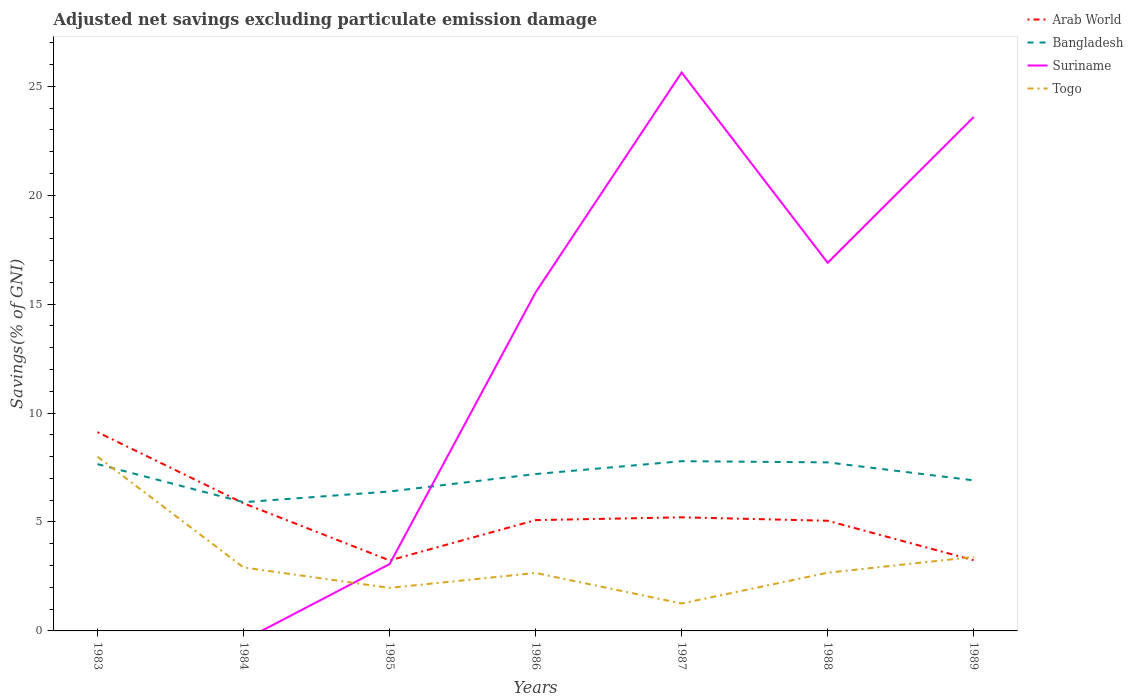Does the line corresponding to Togo intersect with the line corresponding to Arab World?
Offer a very short reply. Yes. Across all years, what is the maximum adjusted net savings in Togo?
Your answer should be compact. 1.26. What is the total adjusted net savings in Togo in the graph?
Keep it short and to the point. 0.24. What is the difference between the highest and the second highest adjusted net savings in Arab World?
Give a very brief answer. 5.89. What is the difference between the highest and the lowest adjusted net savings in Bangladesh?
Your answer should be compact. 4. Is the adjusted net savings in Suriname strictly greater than the adjusted net savings in Bangladesh over the years?
Offer a very short reply. No. How many lines are there?
Your response must be concise. 4. Are the values on the major ticks of Y-axis written in scientific E-notation?
Offer a terse response. No. Does the graph contain grids?
Provide a succinct answer. No. Where does the legend appear in the graph?
Offer a terse response. Top right. What is the title of the graph?
Your response must be concise. Adjusted net savings excluding particulate emission damage. Does "Syrian Arab Republic" appear as one of the legend labels in the graph?
Provide a succinct answer. No. What is the label or title of the Y-axis?
Your answer should be very brief. Savings(% of GNI). What is the Savings(% of GNI) in Arab World in 1983?
Make the answer very short. 9.12. What is the Savings(% of GNI) of Bangladesh in 1983?
Your response must be concise. 7.66. What is the Savings(% of GNI) in Togo in 1983?
Provide a succinct answer. 8. What is the Savings(% of GNI) in Arab World in 1984?
Keep it short and to the point. 5.86. What is the Savings(% of GNI) of Bangladesh in 1984?
Provide a short and direct response. 5.91. What is the Savings(% of GNI) in Togo in 1984?
Offer a very short reply. 2.91. What is the Savings(% of GNI) of Arab World in 1985?
Offer a very short reply. 3.24. What is the Savings(% of GNI) in Bangladesh in 1985?
Provide a succinct answer. 6.4. What is the Savings(% of GNI) of Suriname in 1985?
Offer a terse response. 3.07. What is the Savings(% of GNI) of Togo in 1985?
Offer a very short reply. 1.98. What is the Savings(% of GNI) in Arab World in 1986?
Your response must be concise. 5.09. What is the Savings(% of GNI) of Bangladesh in 1986?
Provide a succinct answer. 7.2. What is the Savings(% of GNI) of Suriname in 1986?
Your answer should be compact. 15.54. What is the Savings(% of GNI) of Togo in 1986?
Ensure brevity in your answer.  2.66. What is the Savings(% of GNI) of Arab World in 1987?
Provide a succinct answer. 5.22. What is the Savings(% of GNI) in Bangladesh in 1987?
Ensure brevity in your answer.  7.79. What is the Savings(% of GNI) in Suriname in 1987?
Offer a very short reply. 25.63. What is the Savings(% of GNI) in Togo in 1987?
Offer a terse response. 1.26. What is the Savings(% of GNI) in Arab World in 1988?
Ensure brevity in your answer.  5.06. What is the Savings(% of GNI) of Bangladesh in 1988?
Provide a succinct answer. 7.74. What is the Savings(% of GNI) in Suriname in 1988?
Offer a terse response. 16.9. What is the Savings(% of GNI) of Togo in 1988?
Make the answer very short. 2.67. What is the Savings(% of GNI) in Arab World in 1989?
Give a very brief answer. 3.24. What is the Savings(% of GNI) of Bangladesh in 1989?
Provide a short and direct response. 6.91. What is the Savings(% of GNI) in Suriname in 1989?
Keep it short and to the point. 23.59. What is the Savings(% of GNI) of Togo in 1989?
Provide a succinct answer. 3.4. Across all years, what is the maximum Savings(% of GNI) in Arab World?
Provide a succinct answer. 9.12. Across all years, what is the maximum Savings(% of GNI) of Bangladesh?
Your answer should be very brief. 7.79. Across all years, what is the maximum Savings(% of GNI) of Suriname?
Give a very brief answer. 25.63. Across all years, what is the maximum Savings(% of GNI) in Togo?
Keep it short and to the point. 8. Across all years, what is the minimum Savings(% of GNI) of Arab World?
Ensure brevity in your answer.  3.24. Across all years, what is the minimum Savings(% of GNI) in Bangladesh?
Make the answer very short. 5.91. Across all years, what is the minimum Savings(% of GNI) in Suriname?
Your answer should be very brief. 0. Across all years, what is the minimum Savings(% of GNI) in Togo?
Offer a very short reply. 1.26. What is the total Savings(% of GNI) of Arab World in the graph?
Ensure brevity in your answer.  36.82. What is the total Savings(% of GNI) of Bangladesh in the graph?
Make the answer very short. 49.61. What is the total Savings(% of GNI) in Suriname in the graph?
Keep it short and to the point. 84.73. What is the total Savings(% of GNI) of Togo in the graph?
Ensure brevity in your answer.  22.87. What is the difference between the Savings(% of GNI) in Arab World in 1983 and that in 1984?
Keep it short and to the point. 3.26. What is the difference between the Savings(% of GNI) in Bangladesh in 1983 and that in 1984?
Offer a terse response. 1.75. What is the difference between the Savings(% of GNI) of Togo in 1983 and that in 1984?
Your answer should be very brief. 5.08. What is the difference between the Savings(% of GNI) of Arab World in 1983 and that in 1985?
Provide a succinct answer. 5.89. What is the difference between the Savings(% of GNI) of Bangladesh in 1983 and that in 1985?
Ensure brevity in your answer.  1.26. What is the difference between the Savings(% of GNI) in Togo in 1983 and that in 1985?
Your answer should be compact. 6.02. What is the difference between the Savings(% of GNI) in Arab World in 1983 and that in 1986?
Make the answer very short. 4.04. What is the difference between the Savings(% of GNI) of Bangladesh in 1983 and that in 1986?
Your answer should be very brief. 0.45. What is the difference between the Savings(% of GNI) of Togo in 1983 and that in 1986?
Provide a short and direct response. 5.34. What is the difference between the Savings(% of GNI) in Arab World in 1983 and that in 1987?
Offer a very short reply. 3.91. What is the difference between the Savings(% of GNI) in Bangladesh in 1983 and that in 1987?
Your response must be concise. -0.13. What is the difference between the Savings(% of GNI) in Togo in 1983 and that in 1987?
Offer a very short reply. 6.74. What is the difference between the Savings(% of GNI) in Arab World in 1983 and that in 1988?
Give a very brief answer. 4.07. What is the difference between the Savings(% of GNI) in Bangladesh in 1983 and that in 1988?
Make the answer very short. -0.08. What is the difference between the Savings(% of GNI) of Togo in 1983 and that in 1988?
Ensure brevity in your answer.  5.33. What is the difference between the Savings(% of GNI) of Arab World in 1983 and that in 1989?
Provide a short and direct response. 5.88. What is the difference between the Savings(% of GNI) in Bangladesh in 1983 and that in 1989?
Offer a terse response. 0.74. What is the difference between the Savings(% of GNI) of Togo in 1983 and that in 1989?
Give a very brief answer. 4.6. What is the difference between the Savings(% of GNI) in Arab World in 1984 and that in 1985?
Offer a terse response. 2.62. What is the difference between the Savings(% of GNI) in Bangladesh in 1984 and that in 1985?
Offer a very short reply. -0.49. What is the difference between the Savings(% of GNI) of Togo in 1984 and that in 1985?
Keep it short and to the point. 0.94. What is the difference between the Savings(% of GNI) of Arab World in 1984 and that in 1986?
Your answer should be very brief. 0.77. What is the difference between the Savings(% of GNI) in Bangladesh in 1984 and that in 1986?
Your answer should be very brief. -1.29. What is the difference between the Savings(% of GNI) in Togo in 1984 and that in 1986?
Your response must be concise. 0.25. What is the difference between the Savings(% of GNI) in Arab World in 1984 and that in 1987?
Your answer should be very brief. 0.64. What is the difference between the Savings(% of GNI) in Bangladesh in 1984 and that in 1987?
Your answer should be very brief. -1.88. What is the difference between the Savings(% of GNI) of Togo in 1984 and that in 1987?
Offer a terse response. 1.65. What is the difference between the Savings(% of GNI) of Arab World in 1984 and that in 1988?
Keep it short and to the point. 0.8. What is the difference between the Savings(% of GNI) of Bangladesh in 1984 and that in 1988?
Provide a short and direct response. -1.83. What is the difference between the Savings(% of GNI) in Togo in 1984 and that in 1988?
Offer a very short reply. 0.24. What is the difference between the Savings(% of GNI) of Arab World in 1984 and that in 1989?
Your response must be concise. 2.62. What is the difference between the Savings(% of GNI) of Bangladesh in 1984 and that in 1989?
Offer a very short reply. -1. What is the difference between the Savings(% of GNI) in Togo in 1984 and that in 1989?
Your response must be concise. -0.48. What is the difference between the Savings(% of GNI) of Arab World in 1985 and that in 1986?
Offer a terse response. -1.85. What is the difference between the Savings(% of GNI) in Bangladesh in 1985 and that in 1986?
Your answer should be very brief. -0.8. What is the difference between the Savings(% of GNI) in Suriname in 1985 and that in 1986?
Offer a very short reply. -12.47. What is the difference between the Savings(% of GNI) of Togo in 1985 and that in 1986?
Keep it short and to the point. -0.69. What is the difference between the Savings(% of GNI) of Arab World in 1985 and that in 1987?
Provide a succinct answer. -1.98. What is the difference between the Savings(% of GNI) of Bangladesh in 1985 and that in 1987?
Offer a very short reply. -1.39. What is the difference between the Savings(% of GNI) in Suriname in 1985 and that in 1987?
Provide a short and direct response. -22.57. What is the difference between the Savings(% of GNI) in Togo in 1985 and that in 1987?
Your answer should be compact. 0.72. What is the difference between the Savings(% of GNI) of Arab World in 1985 and that in 1988?
Keep it short and to the point. -1.82. What is the difference between the Savings(% of GNI) in Bangladesh in 1985 and that in 1988?
Offer a very short reply. -1.34. What is the difference between the Savings(% of GNI) in Suriname in 1985 and that in 1988?
Give a very brief answer. -13.83. What is the difference between the Savings(% of GNI) in Togo in 1985 and that in 1988?
Give a very brief answer. -0.7. What is the difference between the Savings(% of GNI) in Arab World in 1985 and that in 1989?
Keep it short and to the point. -0.01. What is the difference between the Savings(% of GNI) in Bangladesh in 1985 and that in 1989?
Offer a very short reply. -0.51. What is the difference between the Savings(% of GNI) in Suriname in 1985 and that in 1989?
Make the answer very short. -20.52. What is the difference between the Savings(% of GNI) of Togo in 1985 and that in 1989?
Ensure brevity in your answer.  -1.42. What is the difference between the Savings(% of GNI) of Arab World in 1986 and that in 1987?
Your response must be concise. -0.13. What is the difference between the Savings(% of GNI) in Bangladesh in 1986 and that in 1987?
Offer a terse response. -0.59. What is the difference between the Savings(% of GNI) in Suriname in 1986 and that in 1987?
Provide a succinct answer. -10.09. What is the difference between the Savings(% of GNI) in Togo in 1986 and that in 1987?
Keep it short and to the point. 1.4. What is the difference between the Savings(% of GNI) in Arab World in 1986 and that in 1988?
Provide a succinct answer. 0.03. What is the difference between the Savings(% of GNI) in Bangladesh in 1986 and that in 1988?
Give a very brief answer. -0.54. What is the difference between the Savings(% of GNI) of Suriname in 1986 and that in 1988?
Provide a succinct answer. -1.36. What is the difference between the Savings(% of GNI) of Togo in 1986 and that in 1988?
Your response must be concise. -0.01. What is the difference between the Savings(% of GNI) in Arab World in 1986 and that in 1989?
Provide a short and direct response. 1.84. What is the difference between the Savings(% of GNI) of Bangladesh in 1986 and that in 1989?
Offer a terse response. 0.29. What is the difference between the Savings(% of GNI) in Suriname in 1986 and that in 1989?
Your answer should be compact. -8.05. What is the difference between the Savings(% of GNI) of Togo in 1986 and that in 1989?
Keep it short and to the point. -0.74. What is the difference between the Savings(% of GNI) of Arab World in 1987 and that in 1988?
Ensure brevity in your answer.  0.16. What is the difference between the Savings(% of GNI) in Bangladesh in 1987 and that in 1988?
Give a very brief answer. 0.05. What is the difference between the Savings(% of GNI) in Suriname in 1987 and that in 1988?
Offer a very short reply. 8.73. What is the difference between the Savings(% of GNI) in Togo in 1987 and that in 1988?
Your response must be concise. -1.41. What is the difference between the Savings(% of GNI) of Arab World in 1987 and that in 1989?
Your answer should be compact. 1.97. What is the difference between the Savings(% of GNI) in Bangladesh in 1987 and that in 1989?
Offer a very short reply. 0.88. What is the difference between the Savings(% of GNI) of Suriname in 1987 and that in 1989?
Your answer should be very brief. 2.04. What is the difference between the Savings(% of GNI) in Togo in 1987 and that in 1989?
Offer a very short reply. -2.14. What is the difference between the Savings(% of GNI) of Arab World in 1988 and that in 1989?
Make the answer very short. 1.81. What is the difference between the Savings(% of GNI) in Bangladesh in 1988 and that in 1989?
Give a very brief answer. 0.83. What is the difference between the Savings(% of GNI) of Suriname in 1988 and that in 1989?
Offer a very short reply. -6.69. What is the difference between the Savings(% of GNI) in Togo in 1988 and that in 1989?
Provide a short and direct response. -0.72. What is the difference between the Savings(% of GNI) of Arab World in 1983 and the Savings(% of GNI) of Bangladesh in 1984?
Your answer should be very brief. 3.21. What is the difference between the Savings(% of GNI) of Arab World in 1983 and the Savings(% of GNI) of Togo in 1984?
Offer a very short reply. 6.21. What is the difference between the Savings(% of GNI) in Bangladesh in 1983 and the Savings(% of GNI) in Togo in 1984?
Provide a short and direct response. 4.74. What is the difference between the Savings(% of GNI) of Arab World in 1983 and the Savings(% of GNI) of Bangladesh in 1985?
Provide a short and direct response. 2.72. What is the difference between the Savings(% of GNI) in Arab World in 1983 and the Savings(% of GNI) in Suriname in 1985?
Your answer should be compact. 6.06. What is the difference between the Savings(% of GNI) in Arab World in 1983 and the Savings(% of GNI) in Togo in 1985?
Your answer should be compact. 7.15. What is the difference between the Savings(% of GNI) in Bangladesh in 1983 and the Savings(% of GNI) in Suriname in 1985?
Provide a short and direct response. 4.59. What is the difference between the Savings(% of GNI) in Bangladesh in 1983 and the Savings(% of GNI) in Togo in 1985?
Keep it short and to the point. 5.68. What is the difference between the Savings(% of GNI) of Arab World in 1983 and the Savings(% of GNI) of Bangladesh in 1986?
Your answer should be compact. 1.92. What is the difference between the Savings(% of GNI) of Arab World in 1983 and the Savings(% of GNI) of Suriname in 1986?
Make the answer very short. -6.42. What is the difference between the Savings(% of GNI) of Arab World in 1983 and the Savings(% of GNI) of Togo in 1986?
Offer a very short reply. 6.46. What is the difference between the Savings(% of GNI) in Bangladesh in 1983 and the Savings(% of GNI) in Suriname in 1986?
Your response must be concise. -7.88. What is the difference between the Savings(% of GNI) in Bangladesh in 1983 and the Savings(% of GNI) in Togo in 1986?
Offer a very short reply. 5. What is the difference between the Savings(% of GNI) of Arab World in 1983 and the Savings(% of GNI) of Bangladesh in 1987?
Provide a short and direct response. 1.33. What is the difference between the Savings(% of GNI) in Arab World in 1983 and the Savings(% of GNI) in Suriname in 1987?
Keep it short and to the point. -16.51. What is the difference between the Savings(% of GNI) in Arab World in 1983 and the Savings(% of GNI) in Togo in 1987?
Make the answer very short. 7.87. What is the difference between the Savings(% of GNI) of Bangladesh in 1983 and the Savings(% of GNI) of Suriname in 1987?
Your response must be concise. -17.98. What is the difference between the Savings(% of GNI) of Bangladesh in 1983 and the Savings(% of GNI) of Togo in 1987?
Give a very brief answer. 6.4. What is the difference between the Savings(% of GNI) in Arab World in 1983 and the Savings(% of GNI) in Bangladesh in 1988?
Provide a succinct answer. 1.39. What is the difference between the Savings(% of GNI) of Arab World in 1983 and the Savings(% of GNI) of Suriname in 1988?
Make the answer very short. -7.77. What is the difference between the Savings(% of GNI) of Arab World in 1983 and the Savings(% of GNI) of Togo in 1988?
Give a very brief answer. 6.45. What is the difference between the Savings(% of GNI) in Bangladesh in 1983 and the Savings(% of GNI) in Suriname in 1988?
Offer a terse response. -9.24. What is the difference between the Savings(% of GNI) of Bangladesh in 1983 and the Savings(% of GNI) of Togo in 1988?
Keep it short and to the point. 4.99. What is the difference between the Savings(% of GNI) of Arab World in 1983 and the Savings(% of GNI) of Bangladesh in 1989?
Offer a terse response. 2.21. What is the difference between the Savings(% of GNI) in Arab World in 1983 and the Savings(% of GNI) in Suriname in 1989?
Provide a succinct answer. -14.47. What is the difference between the Savings(% of GNI) in Arab World in 1983 and the Savings(% of GNI) in Togo in 1989?
Keep it short and to the point. 5.73. What is the difference between the Savings(% of GNI) of Bangladesh in 1983 and the Savings(% of GNI) of Suriname in 1989?
Your answer should be compact. -15.93. What is the difference between the Savings(% of GNI) in Bangladesh in 1983 and the Savings(% of GNI) in Togo in 1989?
Make the answer very short. 4.26. What is the difference between the Savings(% of GNI) in Arab World in 1984 and the Savings(% of GNI) in Bangladesh in 1985?
Offer a very short reply. -0.54. What is the difference between the Savings(% of GNI) of Arab World in 1984 and the Savings(% of GNI) of Suriname in 1985?
Provide a short and direct response. 2.79. What is the difference between the Savings(% of GNI) in Arab World in 1984 and the Savings(% of GNI) in Togo in 1985?
Offer a terse response. 3.88. What is the difference between the Savings(% of GNI) in Bangladesh in 1984 and the Savings(% of GNI) in Suriname in 1985?
Offer a very short reply. 2.84. What is the difference between the Savings(% of GNI) in Bangladesh in 1984 and the Savings(% of GNI) in Togo in 1985?
Your answer should be very brief. 3.93. What is the difference between the Savings(% of GNI) in Arab World in 1984 and the Savings(% of GNI) in Bangladesh in 1986?
Ensure brevity in your answer.  -1.34. What is the difference between the Savings(% of GNI) of Arab World in 1984 and the Savings(% of GNI) of Suriname in 1986?
Your answer should be very brief. -9.68. What is the difference between the Savings(% of GNI) of Arab World in 1984 and the Savings(% of GNI) of Togo in 1986?
Your answer should be very brief. 3.2. What is the difference between the Savings(% of GNI) in Bangladesh in 1984 and the Savings(% of GNI) in Suriname in 1986?
Offer a very short reply. -9.63. What is the difference between the Savings(% of GNI) of Bangladesh in 1984 and the Savings(% of GNI) of Togo in 1986?
Your answer should be compact. 3.25. What is the difference between the Savings(% of GNI) in Arab World in 1984 and the Savings(% of GNI) in Bangladesh in 1987?
Offer a very short reply. -1.93. What is the difference between the Savings(% of GNI) in Arab World in 1984 and the Savings(% of GNI) in Suriname in 1987?
Your answer should be very brief. -19.77. What is the difference between the Savings(% of GNI) of Arab World in 1984 and the Savings(% of GNI) of Togo in 1987?
Offer a terse response. 4.6. What is the difference between the Savings(% of GNI) in Bangladesh in 1984 and the Savings(% of GNI) in Suriname in 1987?
Offer a very short reply. -19.72. What is the difference between the Savings(% of GNI) in Bangladesh in 1984 and the Savings(% of GNI) in Togo in 1987?
Your response must be concise. 4.65. What is the difference between the Savings(% of GNI) in Arab World in 1984 and the Savings(% of GNI) in Bangladesh in 1988?
Offer a very short reply. -1.88. What is the difference between the Savings(% of GNI) in Arab World in 1984 and the Savings(% of GNI) in Suriname in 1988?
Make the answer very short. -11.04. What is the difference between the Savings(% of GNI) in Arab World in 1984 and the Savings(% of GNI) in Togo in 1988?
Your response must be concise. 3.19. What is the difference between the Savings(% of GNI) in Bangladesh in 1984 and the Savings(% of GNI) in Suriname in 1988?
Make the answer very short. -10.99. What is the difference between the Savings(% of GNI) of Bangladesh in 1984 and the Savings(% of GNI) of Togo in 1988?
Your response must be concise. 3.24. What is the difference between the Savings(% of GNI) in Arab World in 1984 and the Savings(% of GNI) in Bangladesh in 1989?
Offer a terse response. -1.05. What is the difference between the Savings(% of GNI) in Arab World in 1984 and the Savings(% of GNI) in Suriname in 1989?
Keep it short and to the point. -17.73. What is the difference between the Savings(% of GNI) in Arab World in 1984 and the Savings(% of GNI) in Togo in 1989?
Make the answer very short. 2.46. What is the difference between the Savings(% of GNI) of Bangladesh in 1984 and the Savings(% of GNI) of Suriname in 1989?
Make the answer very short. -17.68. What is the difference between the Savings(% of GNI) in Bangladesh in 1984 and the Savings(% of GNI) in Togo in 1989?
Offer a terse response. 2.51. What is the difference between the Savings(% of GNI) in Arab World in 1985 and the Savings(% of GNI) in Bangladesh in 1986?
Your answer should be very brief. -3.97. What is the difference between the Savings(% of GNI) in Arab World in 1985 and the Savings(% of GNI) in Suriname in 1986?
Offer a terse response. -12.3. What is the difference between the Savings(% of GNI) in Arab World in 1985 and the Savings(% of GNI) in Togo in 1986?
Provide a succinct answer. 0.58. What is the difference between the Savings(% of GNI) of Bangladesh in 1985 and the Savings(% of GNI) of Suriname in 1986?
Your answer should be compact. -9.14. What is the difference between the Savings(% of GNI) of Bangladesh in 1985 and the Savings(% of GNI) of Togo in 1986?
Keep it short and to the point. 3.74. What is the difference between the Savings(% of GNI) of Suriname in 1985 and the Savings(% of GNI) of Togo in 1986?
Provide a short and direct response. 0.41. What is the difference between the Savings(% of GNI) of Arab World in 1985 and the Savings(% of GNI) of Bangladesh in 1987?
Make the answer very short. -4.55. What is the difference between the Savings(% of GNI) of Arab World in 1985 and the Savings(% of GNI) of Suriname in 1987?
Your answer should be very brief. -22.4. What is the difference between the Savings(% of GNI) of Arab World in 1985 and the Savings(% of GNI) of Togo in 1987?
Make the answer very short. 1.98. What is the difference between the Savings(% of GNI) in Bangladesh in 1985 and the Savings(% of GNI) in Suriname in 1987?
Provide a short and direct response. -19.23. What is the difference between the Savings(% of GNI) in Bangladesh in 1985 and the Savings(% of GNI) in Togo in 1987?
Your response must be concise. 5.14. What is the difference between the Savings(% of GNI) in Suriname in 1985 and the Savings(% of GNI) in Togo in 1987?
Your response must be concise. 1.81. What is the difference between the Savings(% of GNI) in Arab World in 1985 and the Savings(% of GNI) in Bangladesh in 1988?
Keep it short and to the point. -4.5. What is the difference between the Savings(% of GNI) in Arab World in 1985 and the Savings(% of GNI) in Suriname in 1988?
Ensure brevity in your answer.  -13.66. What is the difference between the Savings(% of GNI) in Arab World in 1985 and the Savings(% of GNI) in Togo in 1988?
Your answer should be very brief. 0.56. What is the difference between the Savings(% of GNI) in Bangladesh in 1985 and the Savings(% of GNI) in Suriname in 1988?
Offer a very short reply. -10.5. What is the difference between the Savings(% of GNI) in Bangladesh in 1985 and the Savings(% of GNI) in Togo in 1988?
Provide a short and direct response. 3.73. What is the difference between the Savings(% of GNI) in Suriname in 1985 and the Savings(% of GNI) in Togo in 1988?
Offer a terse response. 0.4. What is the difference between the Savings(% of GNI) in Arab World in 1985 and the Savings(% of GNI) in Bangladesh in 1989?
Provide a short and direct response. -3.68. What is the difference between the Savings(% of GNI) of Arab World in 1985 and the Savings(% of GNI) of Suriname in 1989?
Provide a short and direct response. -20.35. What is the difference between the Savings(% of GNI) of Arab World in 1985 and the Savings(% of GNI) of Togo in 1989?
Your answer should be very brief. -0.16. What is the difference between the Savings(% of GNI) of Bangladesh in 1985 and the Savings(% of GNI) of Suriname in 1989?
Offer a very short reply. -17.19. What is the difference between the Savings(% of GNI) of Bangladesh in 1985 and the Savings(% of GNI) of Togo in 1989?
Offer a very short reply. 3. What is the difference between the Savings(% of GNI) of Suriname in 1985 and the Savings(% of GNI) of Togo in 1989?
Your response must be concise. -0.33. What is the difference between the Savings(% of GNI) of Arab World in 1986 and the Savings(% of GNI) of Bangladesh in 1987?
Offer a very short reply. -2.71. What is the difference between the Savings(% of GNI) of Arab World in 1986 and the Savings(% of GNI) of Suriname in 1987?
Offer a very short reply. -20.55. What is the difference between the Savings(% of GNI) in Arab World in 1986 and the Savings(% of GNI) in Togo in 1987?
Your answer should be very brief. 3.83. What is the difference between the Savings(% of GNI) in Bangladesh in 1986 and the Savings(% of GNI) in Suriname in 1987?
Provide a short and direct response. -18.43. What is the difference between the Savings(% of GNI) in Bangladesh in 1986 and the Savings(% of GNI) in Togo in 1987?
Provide a short and direct response. 5.94. What is the difference between the Savings(% of GNI) of Suriname in 1986 and the Savings(% of GNI) of Togo in 1987?
Provide a succinct answer. 14.28. What is the difference between the Savings(% of GNI) in Arab World in 1986 and the Savings(% of GNI) in Bangladesh in 1988?
Your answer should be very brief. -2.65. What is the difference between the Savings(% of GNI) in Arab World in 1986 and the Savings(% of GNI) in Suriname in 1988?
Provide a succinct answer. -11.81. What is the difference between the Savings(% of GNI) in Arab World in 1986 and the Savings(% of GNI) in Togo in 1988?
Your answer should be very brief. 2.41. What is the difference between the Savings(% of GNI) of Bangladesh in 1986 and the Savings(% of GNI) of Suriname in 1988?
Your response must be concise. -9.7. What is the difference between the Savings(% of GNI) in Bangladesh in 1986 and the Savings(% of GNI) in Togo in 1988?
Keep it short and to the point. 4.53. What is the difference between the Savings(% of GNI) in Suriname in 1986 and the Savings(% of GNI) in Togo in 1988?
Ensure brevity in your answer.  12.87. What is the difference between the Savings(% of GNI) in Arab World in 1986 and the Savings(% of GNI) in Bangladesh in 1989?
Offer a very short reply. -1.83. What is the difference between the Savings(% of GNI) of Arab World in 1986 and the Savings(% of GNI) of Suriname in 1989?
Ensure brevity in your answer.  -18.5. What is the difference between the Savings(% of GNI) in Arab World in 1986 and the Savings(% of GNI) in Togo in 1989?
Offer a terse response. 1.69. What is the difference between the Savings(% of GNI) in Bangladesh in 1986 and the Savings(% of GNI) in Suriname in 1989?
Make the answer very short. -16.39. What is the difference between the Savings(% of GNI) in Bangladesh in 1986 and the Savings(% of GNI) in Togo in 1989?
Offer a very short reply. 3.81. What is the difference between the Savings(% of GNI) of Suriname in 1986 and the Savings(% of GNI) of Togo in 1989?
Make the answer very short. 12.15. What is the difference between the Savings(% of GNI) of Arab World in 1987 and the Savings(% of GNI) of Bangladesh in 1988?
Provide a succinct answer. -2.52. What is the difference between the Savings(% of GNI) in Arab World in 1987 and the Savings(% of GNI) in Suriname in 1988?
Provide a succinct answer. -11.68. What is the difference between the Savings(% of GNI) in Arab World in 1987 and the Savings(% of GNI) in Togo in 1988?
Offer a terse response. 2.54. What is the difference between the Savings(% of GNI) in Bangladesh in 1987 and the Savings(% of GNI) in Suriname in 1988?
Keep it short and to the point. -9.11. What is the difference between the Savings(% of GNI) of Bangladesh in 1987 and the Savings(% of GNI) of Togo in 1988?
Your answer should be compact. 5.12. What is the difference between the Savings(% of GNI) of Suriname in 1987 and the Savings(% of GNI) of Togo in 1988?
Give a very brief answer. 22.96. What is the difference between the Savings(% of GNI) of Arab World in 1987 and the Savings(% of GNI) of Bangladesh in 1989?
Provide a succinct answer. -1.7. What is the difference between the Savings(% of GNI) of Arab World in 1987 and the Savings(% of GNI) of Suriname in 1989?
Provide a succinct answer. -18.37. What is the difference between the Savings(% of GNI) in Arab World in 1987 and the Savings(% of GNI) in Togo in 1989?
Make the answer very short. 1.82. What is the difference between the Savings(% of GNI) of Bangladesh in 1987 and the Savings(% of GNI) of Suriname in 1989?
Provide a succinct answer. -15.8. What is the difference between the Savings(% of GNI) of Bangladesh in 1987 and the Savings(% of GNI) of Togo in 1989?
Offer a very short reply. 4.4. What is the difference between the Savings(% of GNI) in Suriname in 1987 and the Savings(% of GNI) in Togo in 1989?
Ensure brevity in your answer.  22.24. What is the difference between the Savings(% of GNI) in Arab World in 1988 and the Savings(% of GNI) in Bangladesh in 1989?
Provide a succinct answer. -1.85. What is the difference between the Savings(% of GNI) of Arab World in 1988 and the Savings(% of GNI) of Suriname in 1989?
Keep it short and to the point. -18.53. What is the difference between the Savings(% of GNI) in Arab World in 1988 and the Savings(% of GNI) in Togo in 1989?
Ensure brevity in your answer.  1.66. What is the difference between the Savings(% of GNI) of Bangladesh in 1988 and the Savings(% of GNI) of Suriname in 1989?
Provide a short and direct response. -15.85. What is the difference between the Savings(% of GNI) in Bangladesh in 1988 and the Savings(% of GNI) in Togo in 1989?
Provide a succinct answer. 4.34. What is the difference between the Savings(% of GNI) in Suriname in 1988 and the Savings(% of GNI) in Togo in 1989?
Your response must be concise. 13.5. What is the average Savings(% of GNI) of Arab World per year?
Ensure brevity in your answer.  5.26. What is the average Savings(% of GNI) of Bangladesh per year?
Your response must be concise. 7.09. What is the average Savings(% of GNI) of Suriname per year?
Make the answer very short. 12.1. What is the average Savings(% of GNI) of Togo per year?
Offer a terse response. 3.27. In the year 1983, what is the difference between the Savings(% of GNI) of Arab World and Savings(% of GNI) of Bangladesh?
Your answer should be compact. 1.47. In the year 1983, what is the difference between the Savings(% of GNI) of Arab World and Savings(% of GNI) of Togo?
Provide a succinct answer. 1.13. In the year 1983, what is the difference between the Savings(% of GNI) in Bangladesh and Savings(% of GNI) in Togo?
Give a very brief answer. -0.34. In the year 1984, what is the difference between the Savings(% of GNI) of Arab World and Savings(% of GNI) of Bangladesh?
Provide a succinct answer. -0.05. In the year 1984, what is the difference between the Savings(% of GNI) of Arab World and Savings(% of GNI) of Togo?
Keep it short and to the point. 2.95. In the year 1984, what is the difference between the Savings(% of GNI) of Bangladesh and Savings(% of GNI) of Togo?
Your response must be concise. 3. In the year 1985, what is the difference between the Savings(% of GNI) in Arab World and Savings(% of GNI) in Bangladesh?
Your answer should be very brief. -3.16. In the year 1985, what is the difference between the Savings(% of GNI) in Arab World and Savings(% of GNI) in Suriname?
Keep it short and to the point. 0.17. In the year 1985, what is the difference between the Savings(% of GNI) of Arab World and Savings(% of GNI) of Togo?
Provide a short and direct response. 1.26. In the year 1985, what is the difference between the Savings(% of GNI) of Bangladesh and Savings(% of GNI) of Suriname?
Give a very brief answer. 3.33. In the year 1985, what is the difference between the Savings(% of GNI) in Bangladesh and Savings(% of GNI) in Togo?
Offer a terse response. 4.43. In the year 1985, what is the difference between the Savings(% of GNI) of Suriname and Savings(% of GNI) of Togo?
Give a very brief answer. 1.09. In the year 1986, what is the difference between the Savings(% of GNI) in Arab World and Savings(% of GNI) in Bangladesh?
Offer a terse response. -2.12. In the year 1986, what is the difference between the Savings(% of GNI) in Arab World and Savings(% of GNI) in Suriname?
Give a very brief answer. -10.46. In the year 1986, what is the difference between the Savings(% of GNI) in Arab World and Savings(% of GNI) in Togo?
Your response must be concise. 2.43. In the year 1986, what is the difference between the Savings(% of GNI) of Bangladesh and Savings(% of GNI) of Suriname?
Ensure brevity in your answer.  -8.34. In the year 1986, what is the difference between the Savings(% of GNI) in Bangladesh and Savings(% of GNI) in Togo?
Give a very brief answer. 4.54. In the year 1986, what is the difference between the Savings(% of GNI) in Suriname and Savings(% of GNI) in Togo?
Make the answer very short. 12.88. In the year 1987, what is the difference between the Savings(% of GNI) of Arab World and Savings(% of GNI) of Bangladesh?
Offer a terse response. -2.58. In the year 1987, what is the difference between the Savings(% of GNI) of Arab World and Savings(% of GNI) of Suriname?
Keep it short and to the point. -20.42. In the year 1987, what is the difference between the Savings(% of GNI) in Arab World and Savings(% of GNI) in Togo?
Provide a succinct answer. 3.96. In the year 1987, what is the difference between the Savings(% of GNI) of Bangladesh and Savings(% of GNI) of Suriname?
Make the answer very short. -17.84. In the year 1987, what is the difference between the Savings(% of GNI) of Bangladesh and Savings(% of GNI) of Togo?
Offer a terse response. 6.53. In the year 1987, what is the difference between the Savings(% of GNI) of Suriname and Savings(% of GNI) of Togo?
Your answer should be compact. 24.37. In the year 1988, what is the difference between the Savings(% of GNI) in Arab World and Savings(% of GNI) in Bangladesh?
Offer a terse response. -2.68. In the year 1988, what is the difference between the Savings(% of GNI) of Arab World and Savings(% of GNI) of Suriname?
Offer a very short reply. -11.84. In the year 1988, what is the difference between the Savings(% of GNI) in Arab World and Savings(% of GNI) in Togo?
Your answer should be very brief. 2.39. In the year 1988, what is the difference between the Savings(% of GNI) of Bangladesh and Savings(% of GNI) of Suriname?
Make the answer very short. -9.16. In the year 1988, what is the difference between the Savings(% of GNI) of Bangladesh and Savings(% of GNI) of Togo?
Offer a terse response. 5.07. In the year 1988, what is the difference between the Savings(% of GNI) of Suriname and Savings(% of GNI) of Togo?
Offer a very short reply. 14.23. In the year 1989, what is the difference between the Savings(% of GNI) of Arab World and Savings(% of GNI) of Bangladesh?
Ensure brevity in your answer.  -3.67. In the year 1989, what is the difference between the Savings(% of GNI) in Arab World and Savings(% of GNI) in Suriname?
Provide a succinct answer. -20.35. In the year 1989, what is the difference between the Savings(% of GNI) of Arab World and Savings(% of GNI) of Togo?
Your answer should be very brief. -0.15. In the year 1989, what is the difference between the Savings(% of GNI) in Bangladesh and Savings(% of GNI) in Suriname?
Offer a very short reply. -16.68. In the year 1989, what is the difference between the Savings(% of GNI) of Bangladesh and Savings(% of GNI) of Togo?
Provide a short and direct response. 3.52. In the year 1989, what is the difference between the Savings(% of GNI) in Suriname and Savings(% of GNI) in Togo?
Provide a succinct answer. 20.19. What is the ratio of the Savings(% of GNI) in Arab World in 1983 to that in 1984?
Offer a very short reply. 1.56. What is the ratio of the Savings(% of GNI) of Bangladesh in 1983 to that in 1984?
Provide a succinct answer. 1.3. What is the ratio of the Savings(% of GNI) of Togo in 1983 to that in 1984?
Keep it short and to the point. 2.75. What is the ratio of the Savings(% of GNI) in Arab World in 1983 to that in 1985?
Provide a succinct answer. 2.82. What is the ratio of the Savings(% of GNI) of Bangladesh in 1983 to that in 1985?
Keep it short and to the point. 1.2. What is the ratio of the Savings(% of GNI) of Togo in 1983 to that in 1985?
Your answer should be very brief. 4.05. What is the ratio of the Savings(% of GNI) of Arab World in 1983 to that in 1986?
Give a very brief answer. 1.79. What is the ratio of the Savings(% of GNI) of Bangladesh in 1983 to that in 1986?
Offer a very short reply. 1.06. What is the ratio of the Savings(% of GNI) of Togo in 1983 to that in 1986?
Ensure brevity in your answer.  3.01. What is the ratio of the Savings(% of GNI) of Arab World in 1983 to that in 1987?
Your response must be concise. 1.75. What is the ratio of the Savings(% of GNI) in Bangladesh in 1983 to that in 1987?
Offer a terse response. 0.98. What is the ratio of the Savings(% of GNI) of Togo in 1983 to that in 1987?
Your response must be concise. 6.35. What is the ratio of the Savings(% of GNI) of Arab World in 1983 to that in 1988?
Offer a terse response. 1.8. What is the ratio of the Savings(% of GNI) of Togo in 1983 to that in 1988?
Provide a short and direct response. 2.99. What is the ratio of the Savings(% of GNI) of Arab World in 1983 to that in 1989?
Provide a short and direct response. 2.81. What is the ratio of the Savings(% of GNI) in Bangladesh in 1983 to that in 1989?
Give a very brief answer. 1.11. What is the ratio of the Savings(% of GNI) in Togo in 1983 to that in 1989?
Your answer should be very brief. 2.36. What is the ratio of the Savings(% of GNI) of Arab World in 1984 to that in 1985?
Keep it short and to the point. 1.81. What is the ratio of the Savings(% of GNI) in Bangladesh in 1984 to that in 1985?
Make the answer very short. 0.92. What is the ratio of the Savings(% of GNI) in Togo in 1984 to that in 1985?
Give a very brief answer. 1.48. What is the ratio of the Savings(% of GNI) of Arab World in 1984 to that in 1986?
Offer a very short reply. 1.15. What is the ratio of the Savings(% of GNI) of Bangladesh in 1984 to that in 1986?
Ensure brevity in your answer.  0.82. What is the ratio of the Savings(% of GNI) of Togo in 1984 to that in 1986?
Give a very brief answer. 1.1. What is the ratio of the Savings(% of GNI) of Arab World in 1984 to that in 1987?
Make the answer very short. 1.12. What is the ratio of the Savings(% of GNI) of Bangladesh in 1984 to that in 1987?
Provide a short and direct response. 0.76. What is the ratio of the Savings(% of GNI) in Togo in 1984 to that in 1987?
Make the answer very short. 2.31. What is the ratio of the Savings(% of GNI) in Arab World in 1984 to that in 1988?
Provide a succinct answer. 1.16. What is the ratio of the Savings(% of GNI) in Bangladesh in 1984 to that in 1988?
Keep it short and to the point. 0.76. What is the ratio of the Savings(% of GNI) of Togo in 1984 to that in 1988?
Your answer should be compact. 1.09. What is the ratio of the Savings(% of GNI) of Arab World in 1984 to that in 1989?
Offer a terse response. 1.81. What is the ratio of the Savings(% of GNI) in Bangladesh in 1984 to that in 1989?
Offer a terse response. 0.85. What is the ratio of the Savings(% of GNI) in Togo in 1984 to that in 1989?
Ensure brevity in your answer.  0.86. What is the ratio of the Savings(% of GNI) of Arab World in 1985 to that in 1986?
Give a very brief answer. 0.64. What is the ratio of the Savings(% of GNI) in Bangladesh in 1985 to that in 1986?
Ensure brevity in your answer.  0.89. What is the ratio of the Savings(% of GNI) of Suriname in 1985 to that in 1986?
Provide a succinct answer. 0.2. What is the ratio of the Savings(% of GNI) of Togo in 1985 to that in 1986?
Offer a very short reply. 0.74. What is the ratio of the Savings(% of GNI) of Arab World in 1985 to that in 1987?
Offer a very short reply. 0.62. What is the ratio of the Savings(% of GNI) of Bangladesh in 1985 to that in 1987?
Your answer should be very brief. 0.82. What is the ratio of the Savings(% of GNI) in Suriname in 1985 to that in 1987?
Offer a terse response. 0.12. What is the ratio of the Savings(% of GNI) of Togo in 1985 to that in 1987?
Your answer should be compact. 1.57. What is the ratio of the Savings(% of GNI) in Arab World in 1985 to that in 1988?
Provide a short and direct response. 0.64. What is the ratio of the Savings(% of GNI) of Bangladesh in 1985 to that in 1988?
Ensure brevity in your answer.  0.83. What is the ratio of the Savings(% of GNI) of Suriname in 1985 to that in 1988?
Keep it short and to the point. 0.18. What is the ratio of the Savings(% of GNI) of Togo in 1985 to that in 1988?
Your answer should be very brief. 0.74. What is the ratio of the Savings(% of GNI) of Arab World in 1985 to that in 1989?
Give a very brief answer. 1. What is the ratio of the Savings(% of GNI) in Bangladesh in 1985 to that in 1989?
Give a very brief answer. 0.93. What is the ratio of the Savings(% of GNI) of Suriname in 1985 to that in 1989?
Give a very brief answer. 0.13. What is the ratio of the Savings(% of GNI) of Togo in 1985 to that in 1989?
Offer a terse response. 0.58. What is the ratio of the Savings(% of GNI) of Arab World in 1986 to that in 1987?
Ensure brevity in your answer.  0.98. What is the ratio of the Savings(% of GNI) in Bangladesh in 1986 to that in 1987?
Your response must be concise. 0.92. What is the ratio of the Savings(% of GNI) in Suriname in 1986 to that in 1987?
Give a very brief answer. 0.61. What is the ratio of the Savings(% of GNI) in Togo in 1986 to that in 1987?
Your answer should be very brief. 2.11. What is the ratio of the Savings(% of GNI) in Arab World in 1986 to that in 1988?
Give a very brief answer. 1.01. What is the ratio of the Savings(% of GNI) of Bangladesh in 1986 to that in 1988?
Provide a short and direct response. 0.93. What is the ratio of the Savings(% of GNI) in Suriname in 1986 to that in 1988?
Keep it short and to the point. 0.92. What is the ratio of the Savings(% of GNI) of Arab World in 1986 to that in 1989?
Ensure brevity in your answer.  1.57. What is the ratio of the Savings(% of GNI) of Bangladesh in 1986 to that in 1989?
Offer a terse response. 1.04. What is the ratio of the Savings(% of GNI) in Suriname in 1986 to that in 1989?
Keep it short and to the point. 0.66. What is the ratio of the Savings(% of GNI) in Togo in 1986 to that in 1989?
Provide a short and direct response. 0.78. What is the ratio of the Savings(% of GNI) in Arab World in 1987 to that in 1988?
Make the answer very short. 1.03. What is the ratio of the Savings(% of GNI) of Suriname in 1987 to that in 1988?
Your response must be concise. 1.52. What is the ratio of the Savings(% of GNI) in Togo in 1987 to that in 1988?
Provide a short and direct response. 0.47. What is the ratio of the Savings(% of GNI) of Arab World in 1987 to that in 1989?
Provide a succinct answer. 1.61. What is the ratio of the Savings(% of GNI) of Bangladesh in 1987 to that in 1989?
Provide a short and direct response. 1.13. What is the ratio of the Savings(% of GNI) of Suriname in 1987 to that in 1989?
Provide a short and direct response. 1.09. What is the ratio of the Savings(% of GNI) of Togo in 1987 to that in 1989?
Provide a short and direct response. 0.37. What is the ratio of the Savings(% of GNI) of Arab World in 1988 to that in 1989?
Provide a short and direct response. 1.56. What is the ratio of the Savings(% of GNI) in Bangladesh in 1988 to that in 1989?
Offer a terse response. 1.12. What is the ratio of the Savings(% of GNI) of Suriname in 1988 to that in 1989?
Give a very brief answer. 0.72. What is the ratio of the Savings(% of GNI) in Togo in 1988 to that in 1989?
Provide a short and direct response. 0.79. What is the difference between the highest and the second highest Savings(% of GNI) in Arab World?
Keep it short and to the point. 3.26. What is the difference between the highest and the second highest Savings(% of GNI) in Bangladesh?
Offer a terse response. 0.05. What is the difference between the highest and the second highest Savings(% of GNI) of Suriname?
Offer a terse response. 2.04. What is the difference between the highest and the second highest Savings(% of GNI) in Togo?
Provide a short and direct response. 4.6. What is the difference between the highest and the lowest Savings(% of GNI) in Arab World?
Make the answer very short. 5.89. What is the difference between the highest and the lowest Savings(% of GNI) in Bangladesh?
Keep it short and to the point. 1.88. What is the difference between the highest and the lowest Savings(% of GNI) of Suriname?
Your answer should be very brief. 25.63. What is the difference between the highest and the lowest Savings(% of GNI) in Togo?
Make the answer very short. 6.74. 